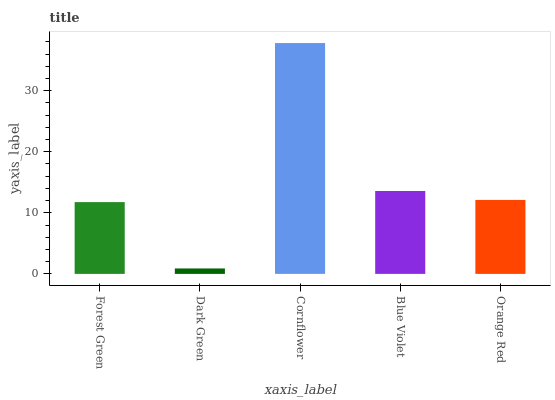Is Dark Green the minimum?
Answer yes or no. Yes. Is Cornflower the maximum?
Answer yes or no. Yes. Is Cornflower the minimum?
Answer yes or no. No. Is Dark Green the maximum?
Answer yes or no. No. Is Cornflower greater than Dark Green?
Answer yes or no. Yes. Is Dark Green less than Cornflower?
Answer yes or no. Yes. Is Dark Green greater than Cornflower?
Answer yes or no. No. Is Cornflower less than Dark Green?
Answer yes or no. No. Is Orange Red the high median?
Answer yes or no. Yes. Is Orange Red the low median?
Answer yes or no. Yes. Is Blue Violet the high median?
Answer yes or no. No. Is Blue Violet the low median?
Answer yes or no. No. 